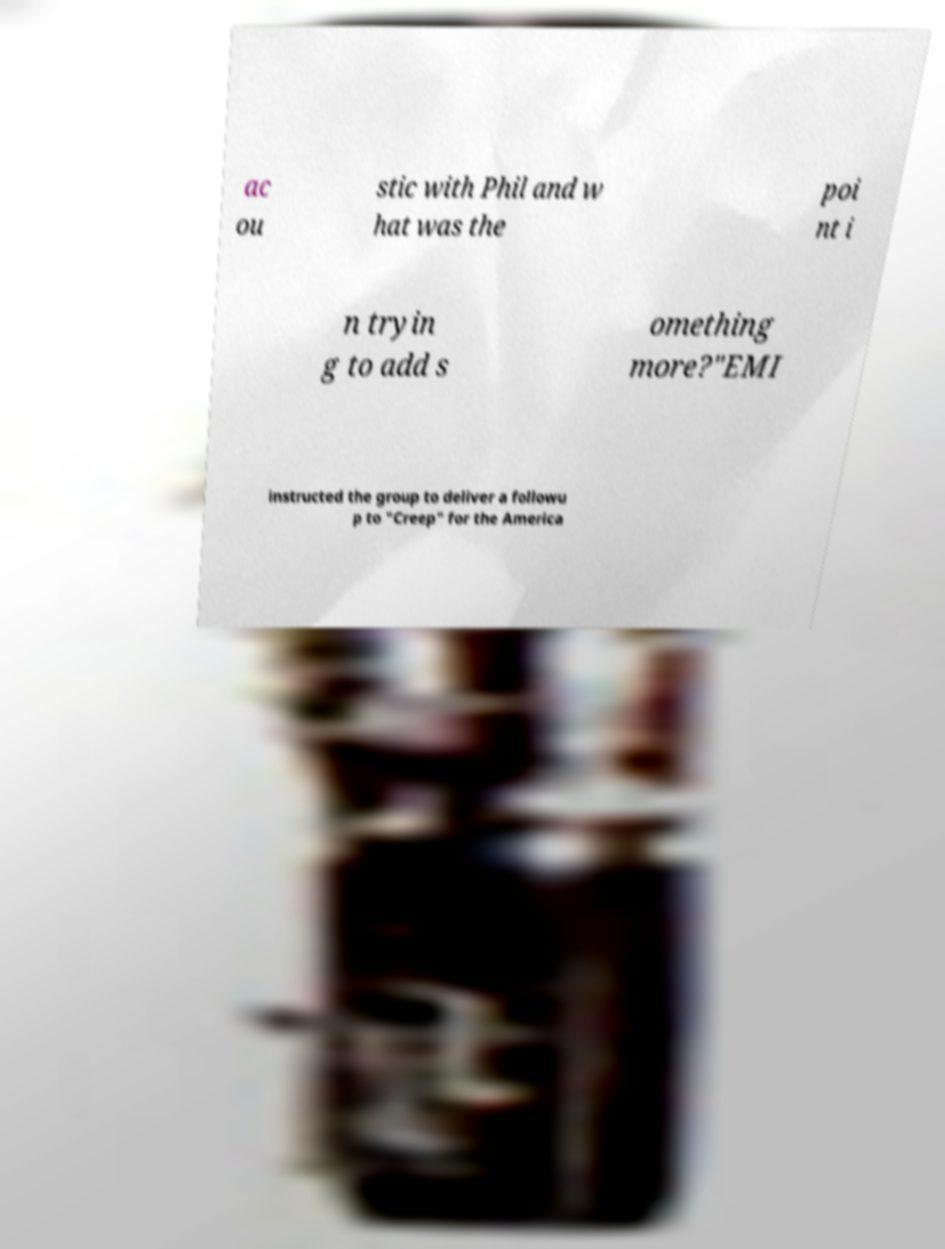For documentation purposes, I need the text within this image transcribed. Could you provide that? ac ou stic with Phil and w hat was the poi nt i n tryin g to add s omething more?"EMI instructed the group to deliver a followu p to "Creep" for the America 